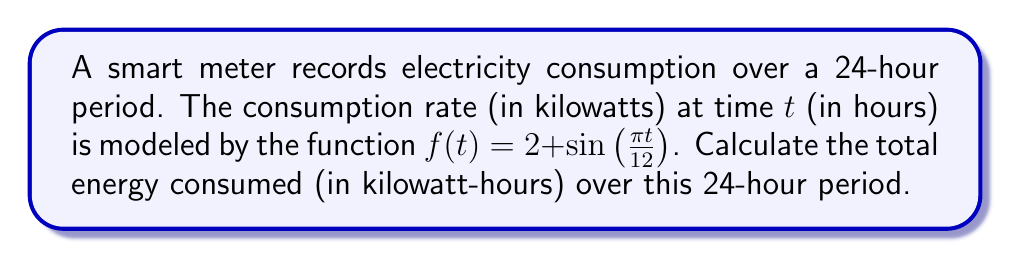Can you answer this question? To solve this problem, we need to integrate the consumption rate function over the given time period. Here's a step-by-step approach:

1) The total energy consumed is equal to the area under the consumption curve. We can calculate this using a definite integral:

   $$E = \int_{0}^{24} f(t) dt$$

2) Substituting our function:

   $$E = \int_{0}^{24} (2 + \sin(\frac{\pi t}{12})) dt$$

3) We can split this into two integrals:

   $$E = \int_{0}^{24} 2 dt + \int_{0}^{24} \sin(\frac{\pi t}{12}) dt$$

4) For the first integral:

   $$\int_{0}^{24} 2 dt = 2t \bigg|_{0}^{24} = 2(24) - 2(0) = 48$$

5) For the second integral, we use the substitution $u = \frac{\pi t}{12}$:

   $$\int_{0}^{24} \sin(\frac{\pi t}{12}) dt = \frac{12}{\pi} \int_{0}^{2\pi} \sin(u) du$$

6) Evaluating this integral:

   $$\frac{12}{\pi} [-\cos(u)]_{0}^{2\pi} = \frac{12}{\pi} [-\cos(2\pi) + \cos(0)] = 0$$

7) Adding the results from steps 4 and 6:

   $$E = 48 + 0 = 48$$

Therefore, the total energy consumed over the 24-hour period is 48 kilowatt-hours.
Answer: 48 kWh 